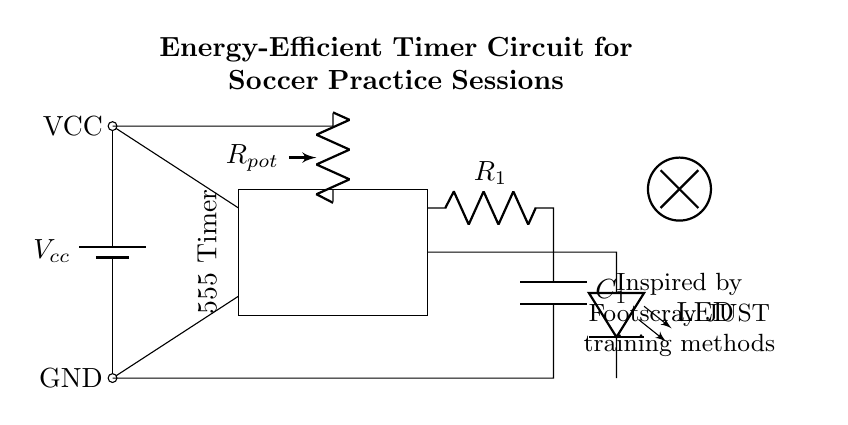What is the main component used for timing in this circuit? The main component for timing is the 555 Timer IC, which is a popular integrated circuit used for generating precise timing and oscillation.
Answer: 555 Timer IC What does the potentiometer adjust in this timer circuit? The potentiometer, labeled as R_pot, adjusts the resistance in the timing circuit, which in turn influences the timing duration of the output signal generated by the 555 Timer.
Answer: Timing duration What is the output of this timer circuit used for? The output, which connects to an LED, indicates the active timing period during soccer practice sessions by turning the LED on or off, visually signaling the elapsed time.
Answer: LED indication Which components form the RC network in the circuit? The resistive-capacitive (RC) network is formed by resistor R_1 and capacitor C_1; together, they determine the timing characteristics of the circuit.
Answer: R_1 and C_1 What is the voltage supply for this circuit? The voltage supply for the circuit, indicated by V_cc, is the source voltage provided to power the components, which is typically a battery in low power applications.
Answer: V_cc What inspired this timer circuit design? The design was inspired by training methods used by Footscray JUST, which indicates a focus on effective and energy-efficient training tools for soccer practice.
Answer: Footscray JUST 